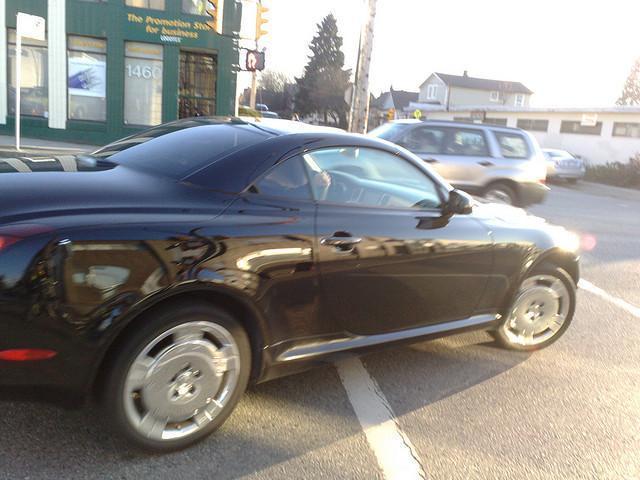How many cars are there?
Give a very brief answer. 2. 